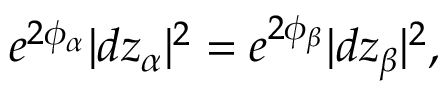Convert formula to latex. <formula><loc_0><loc_0><loc_500><loc_500>e ^ { 2 \phi _ { \alpha } } | d z _ { \alpha } | ^ { 2 } = e ^ { 2 \phi _ { \beta } } | d z _ { \beta } | ^ { 2 } ,</formula> 